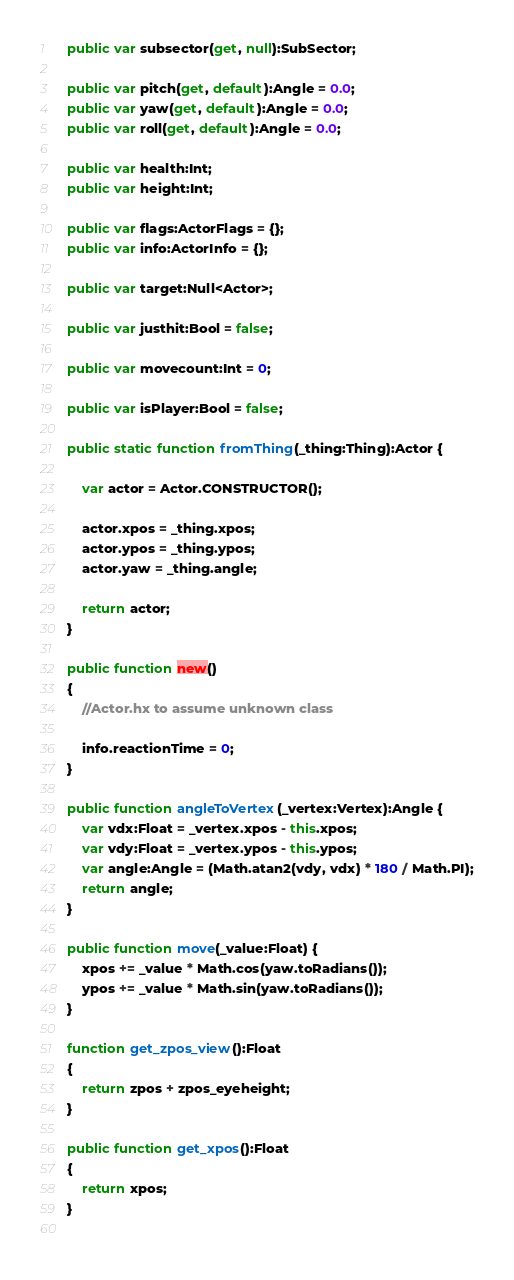<code> <loc_0><loc_0><loc_500><loc_500><_Haxe_>	public var subsector(get, null):SubSector;
	
	public var pitch(get, default):Angle = 0.0;
	public var yaw(get, default):Angle = 0.0;
	public var roll(get, default):Angle = 0.0;
	
	public var health:Int;
	public var height:Int;
	
	public var flags:ActorFlags = {};
	public var info:ActorInfo = {};
	
	public var target:Null<Actor>;
	
	public var justhit:Bool = false;
	
	public var movecount:Int = 0;
	
	public var isPlayer:Bool = false;
	
	public static function fromThing(_thing:Thing):Actor {
		
		var actor = Actor.CONSTRUCTOR();
		
		actor.xpos = _thing.xpos;
		actor.ypos = _thing.ypos;
		actor.yaw = _thing.angle;
		
		return actor;
	}
	
	public function new() 
	{
		//Actor.hx to assume unknown class
		
		info.reactionTime = 0;
	}
	
	public function angleToVertex(_vertex:Vertex):Angle {
		var vdx:Float = _vertex.xpos - this.xpos;
		var vdy:Float = _vertex.ypos - this.ypos;
		var angle:Angle = (Math.atan2(vdy, vdx) * 180 / Math.PI);
		return angle;
	}
	
	public function move(_value:Float) {
		xpos += _value * Math.cos(yaw.toRadians());
		ypos += _value * Math.sin(yaw.toRadians());
	}
	
	function get_zpos_view():Float 
	{
		return zpos + zpos_eyeheight;
	}
	
	public function get_xpos():Float 
	{
		return xpos;
	}
	</code> 